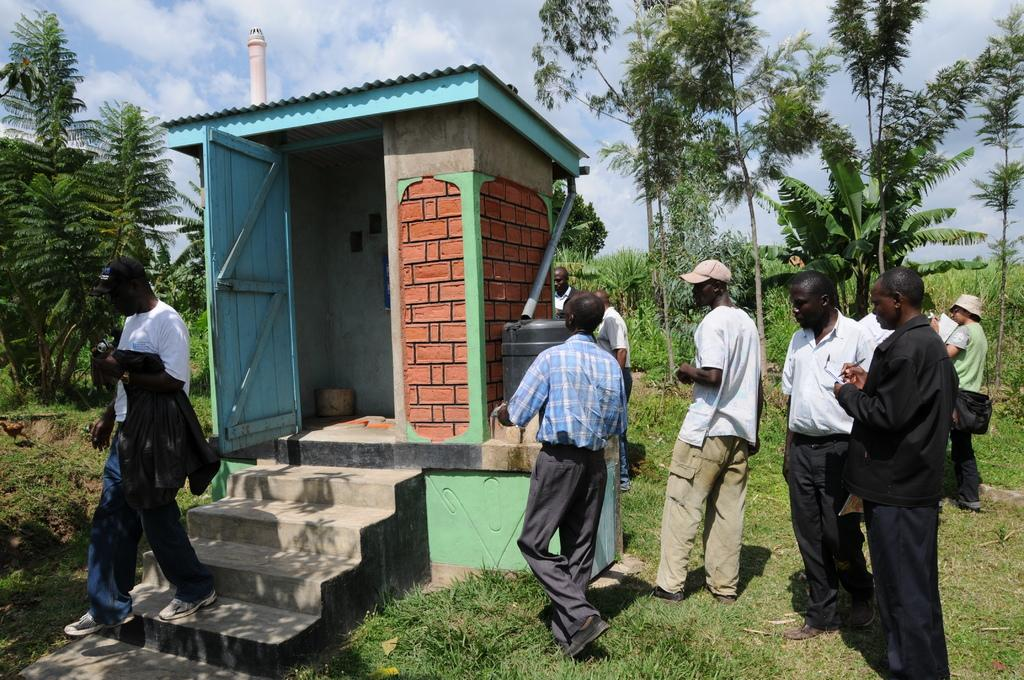What type of room is depicted in the image? There is a small bathroom in the image. Who is present in the image? There is a group of men standing around the bathroom. What can be seen in the background of the image? There are many plants and trees in the image. What is the surface on which the plants and trees are located? The plants and trees are on a grass surface. What note is the drummer playing in the image? There is no drum or drummer present in the image. What time of day is it in the image? The provided facts do not mention the time of day, so it cannot be determined from the image. 